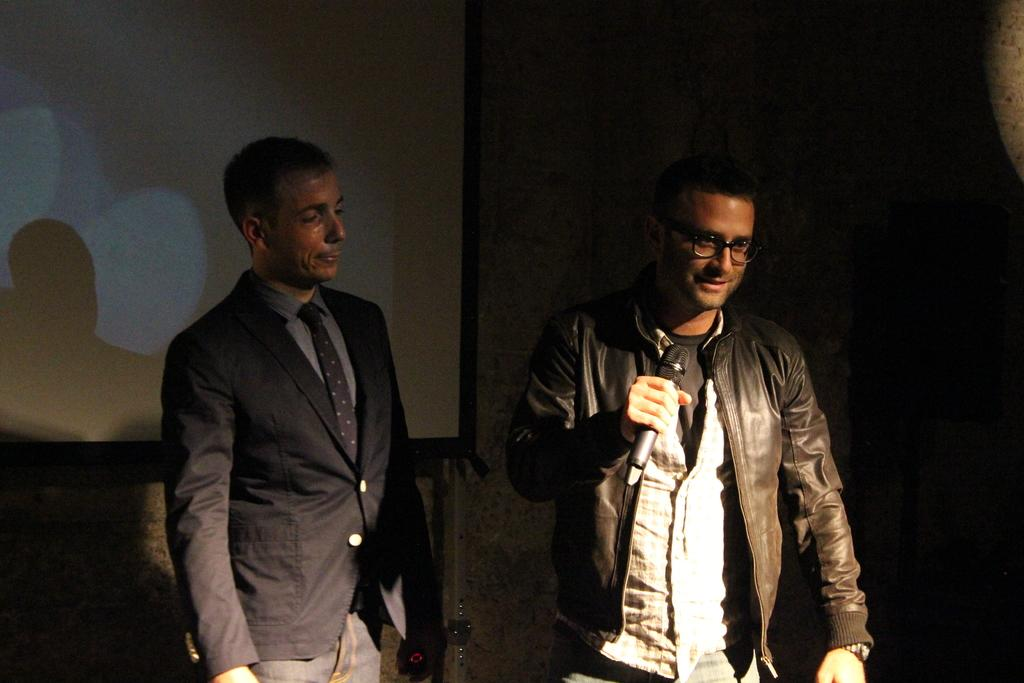How many people are in the image? There are two men in the image. What is one of the men holding? One of the men is holding a mic. What is the man holding the mic wearing? The man holding the mic is wearing a jacket. What can be seen on the wall in the background of the image? There is a projector display screen in the image. What is the primary architectural feature in the background of the image? There is a wall in the background of the image. What type of liquid is being poured from the engine in the image? There is no engine or liquid present in the image. How many police officers can be seen in the image? There are no police officers present in the image. 